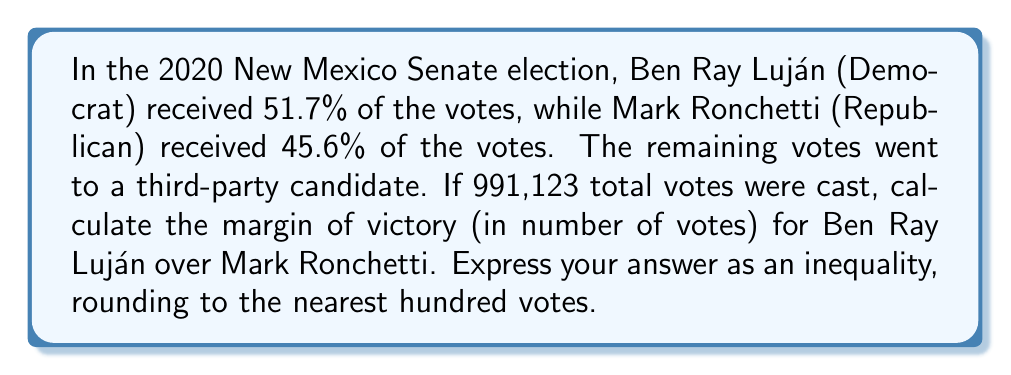Teach me how to tackle this problem. Let's approach this step-by-step:

1) First, calculate the number of votes received by each candidate:

   Luján: $991,123 \times 0.517 = 512,410.591$
   Ronchetti: $991,123 \times 0.456 = 451,952.088$

2) The margin of victory is the difference between these two numbers:

   $512,410.591 - 451,952.088 = 60,458.503$

3) Rounding to the nearest hundred:

   $60,458.503 \approx 60,500$

4) To express this as an inequality, we can say that the actual margin of victory is within 50 votes of our rounded number:

   $60,450 < \text{margin of victory} < 60,550$

This inequality accounts for the rounding and potential small discrepancies due to the exact vote counts not being provided.
Answer: $60,450 < \text{margin of victory} < 60,550$ 